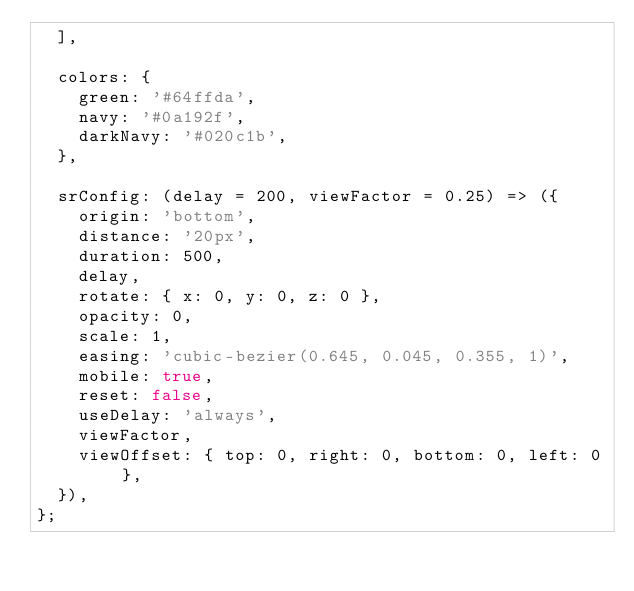<code> <loc_0><loc_0><loc_500><loc_500><_JavaScript_>  ],

  colors: {
    green: '#64ffda',
    navy: '#0a192f',
    darkNavy: '#020c1b',
  },

  srConfig: (delay = 200, viewFactor = 0.25) => ({
    origin: 'bottom',
    distance: '20px',
    duration: 500,
    delay,
    rotate: { x: 0, y: 0, z: 0 },
    opacity: 0,
    scale: 1,
    easing: 'cubic-bezier(0.645, 0.045, 0.355, 1)',
    mobile: true,
    reset: false,
    useDelay: 'always',
    viewFactor,
    viewOffset: { top: 0, right: 0, bottom: 0, left: 0 },
  }),
};
</code> 